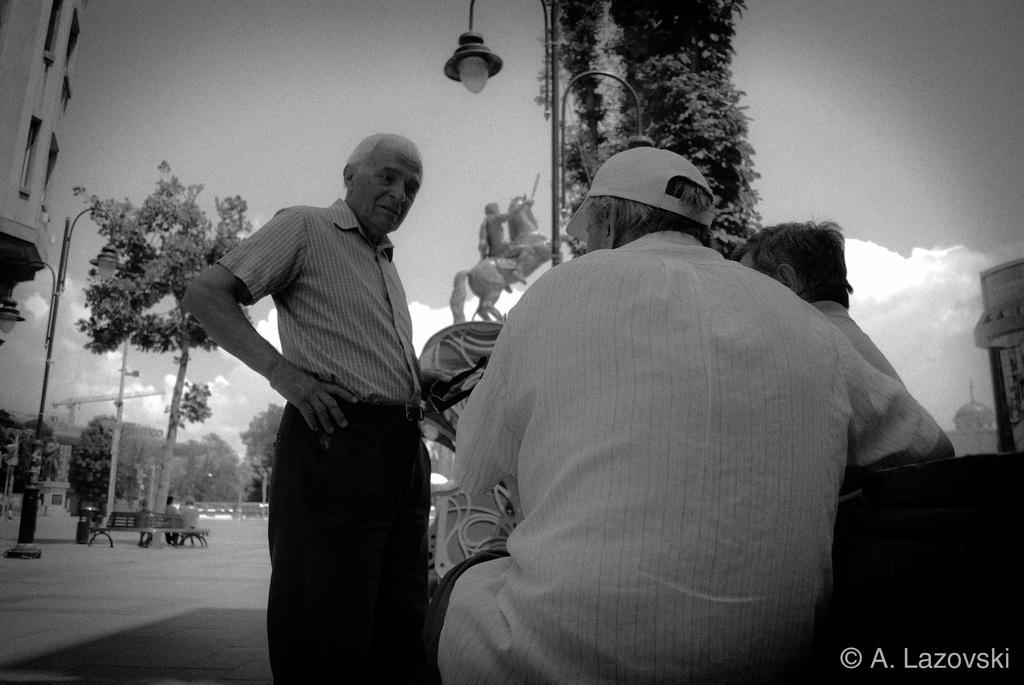In one or two sentences, can you explain what this image depicts? In this image I can see the group of people with the dresses. I can see one person wearing the cap. In the back I can see the statue and the light pole. To the left I can see the building. I can also see few people sitting on the bench. In the back there are many trees and the sky. 